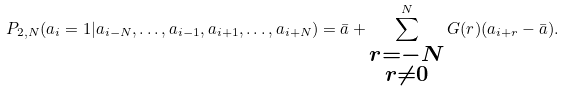Convert formula to latex. <formula><loc_0><loc_0><loc_500><loc_500>P _ { 2 , N } ( a _ { i } = 1 | a _ { i - N } , \dots , a _ { i - 1 } , a _ { i + 1 } , \dots , a _ { i + N } ) = \bar { a } + \sum _ { \substack { r = - N \\ r \neq 0 } } ^ { N } G ( r ) ( a _ { i + r } - \bar { a } ) .</formula> 